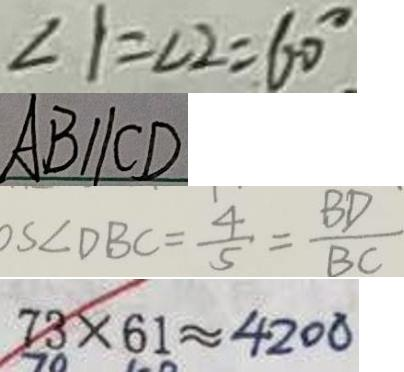Convert formula to latex. <formula><loc_0><loc_0><loc_500><loc_500>\angle 1 = \angle 2 = 6 0 ^ { \circ } 
 A B / / C D 
 o s \angle D B C = \frac { 4 } { 5 } = \frac { B D } { B C } 
 7 3 \times 6 1 \approx 4 2 0 0</formula> 